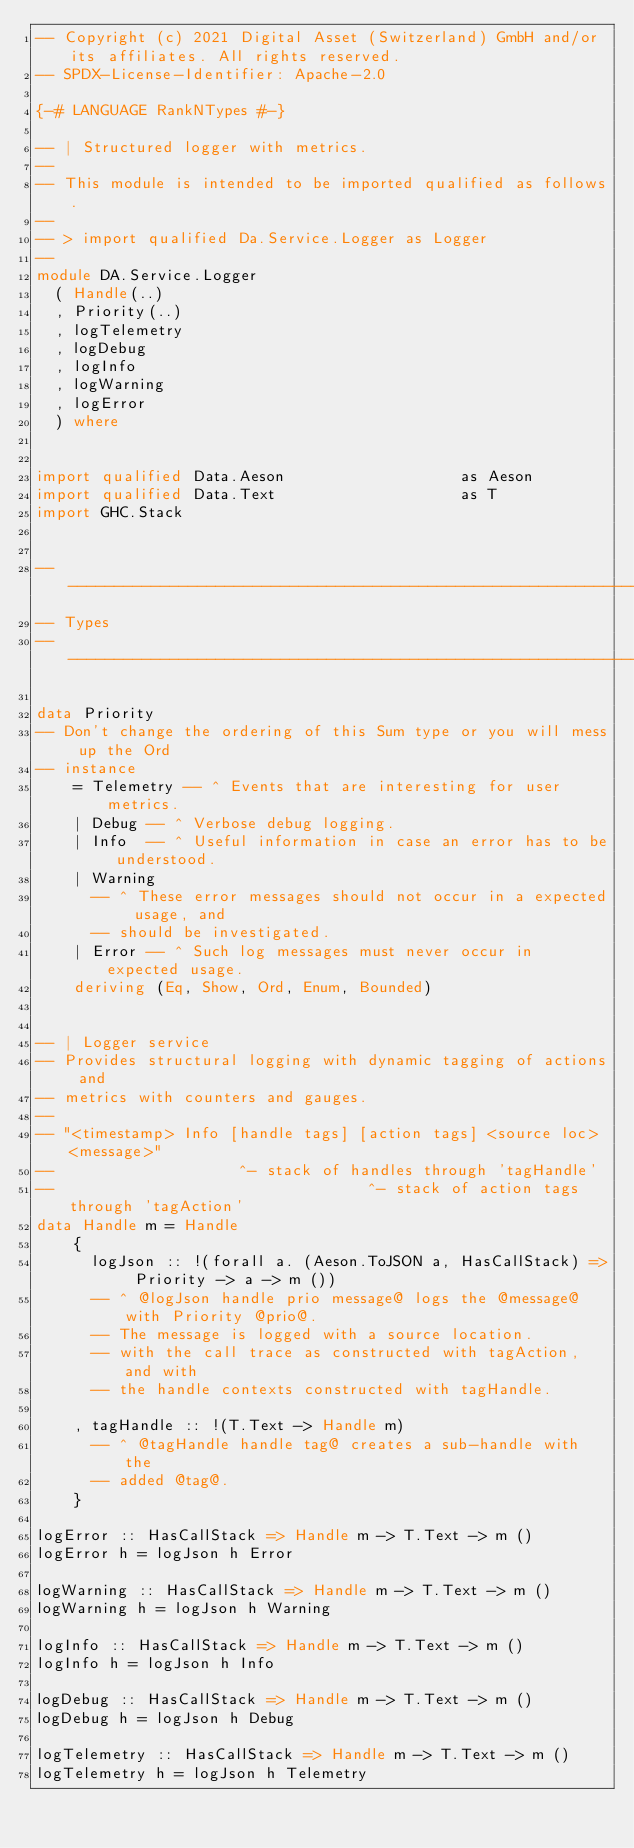Convert code to text. <code><loc_0><loc_0><loc_500><loc_500><_Haskell_>-- Copyright (c) 2021 Digital Asset (Switzerland) GmbH and/or its affiliates. All rights reserved.
-- SPDX-License-Identifier: Apache-2.0

{-# LANGUAGE RankNTypes #-}

-- | Structured logger with metrics.
--
-- This module is intended to be imported qualified as follows.
--
-- > import qualified Da.Service.Logger as Logger
--
module DA.Service.Logger
  ( Handle(..)
  , Priority(..)
  , logTelemetry
  , logDebug
  , logInfo
  , logWarning
  , logError
  ) where


import qualified Data.Aeson                   as Aeson
import qualified Data.Text                    as T
import GHC.Stack


------------------------------------------------------------------------------
-- Types
------------------------------------------------------------------------------

data Priority
-- Don't change the ordering of this Sum type or you will mess up the Ord
-- instance
    = Telemetry -- ^ Events that are interesting for user metrics.
    | Debug -- ^ Verbose debug logging.
    | Info  -- ^ Useful information in case an error has to be understood.
    | Warning
      -- ^ These error messages should not occur in a expected usage, and
      -- should be investigated.
    | Error -- ^ Such log messages must never occur in expected usage.
    deriving (Eq, Show, Ord, Enum, Bounded)


-- | Logger service
-- Provides structural logging with dynamic tagging of actions and
-- metrics with counters and gauges.
--
-- "<timestamp> Info [handle tags] [action tags] <source loc> <message>"
--                    ^- stack of handles through 'tagHandle'
--                                  ^- stack of action tags through 'tagAction'
data Handle m = Handle
    {
      logJson :: !(forall a. (Aeson.ToJSON a, HasCallStack) => Priority -> a -> m ())
      -- ^ @logJson handle prio message@ logs the @message@ with Priority @prio@.
      -- The message is logged with a source location.
      -- with the call trace as constructed with tagAction, and with
      -- the handle contexts constructed with tagHandle.

    , tagHandle :: !(T.Text -> Handle m)
      -- ^ @tagHandle handle tag@ creates a sub-handle with the
      -- added @tag@.
    }

logError :: HasCallStack => Handle m -> T.Text -> m ()
logError h = logJson h Error

logWarning :: HasCallStack => Handle m -> T.Text -> m ()
logWarning h = logJson h Warning

logInfo :: HasCallStack => Handle m -> T.Text -> m ()
logInfo h = logJson h Info

logDebug :: HasCallStack => Handle m -> T.Text -> m ()
logDebug h = logJson h Debug

logTelemetry :: HasCallStack => Handle m -> T.Text -> m ()
logTelemetry h = logJson h Telemetry
</code> 